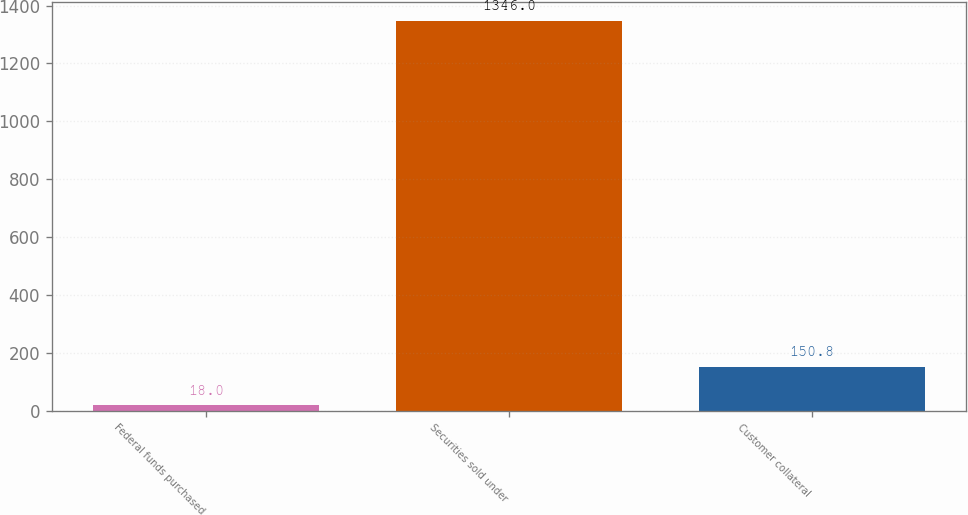Convert chart. <chart><loc_0><loc_0><loc_500><loc_500><bar_chart><fcel>Federal funds purchased<fcel>Securities sold under<fcel>Customer collateral<nl><fcel>18<fcel>1346<fcel>150.8<nl></chart> 